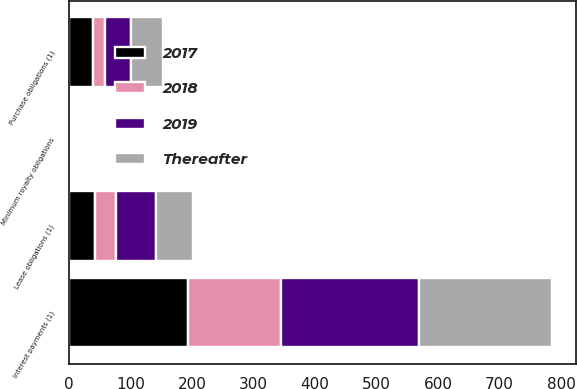Convert chart. <chart><loc_0><loc_0><loc_500><loc_500><stacked_bar_chart><ecel><fcel>Interest payments (1)<fcel>Lease obligations (1)<fcel>Purchase obligations (1)<fcel>Minimum royalty obligations<nl><fcel>2019<fcel>224<fcel>66<fcel>42<fcel>1<nl><fcel>Thereafter<fcel>216<fcel>60<fcel>52<fcel>2<nl><fcel>2017<fcel>194<fcel>42<fcel>39<fcel>1<nl><fcel>2018<fcel>151<fcel>34<fcel>19<fcel>2<nl></chart> 